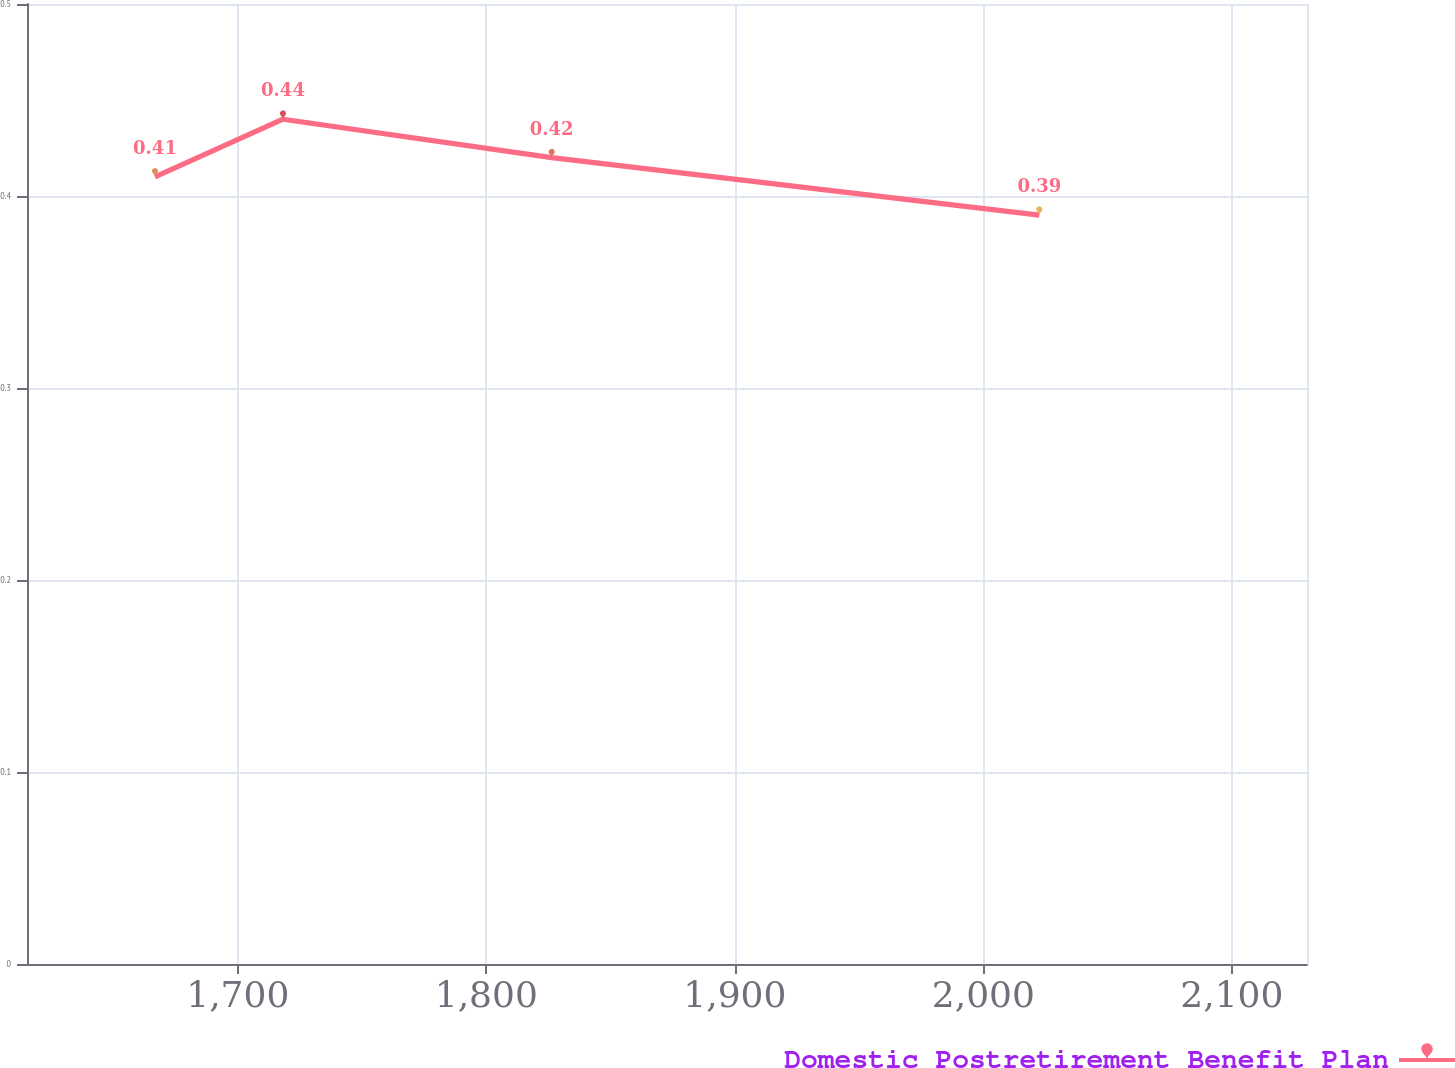<chart> <loc_0><loc_0><loc_500><loc_500><line_chart><ecel><fcel>Domestic Postretirement Benefit Plan<nl><fcel>1666.7<fcel>0.41<nl><fcel>1718.2<fcel>0.44<nl><fcel>1826.32<fcel>0.42<nl><fcel>2022.52<fcel>0.39<nl><fcel>2181.73<fcel>0.32<nl></chart> 